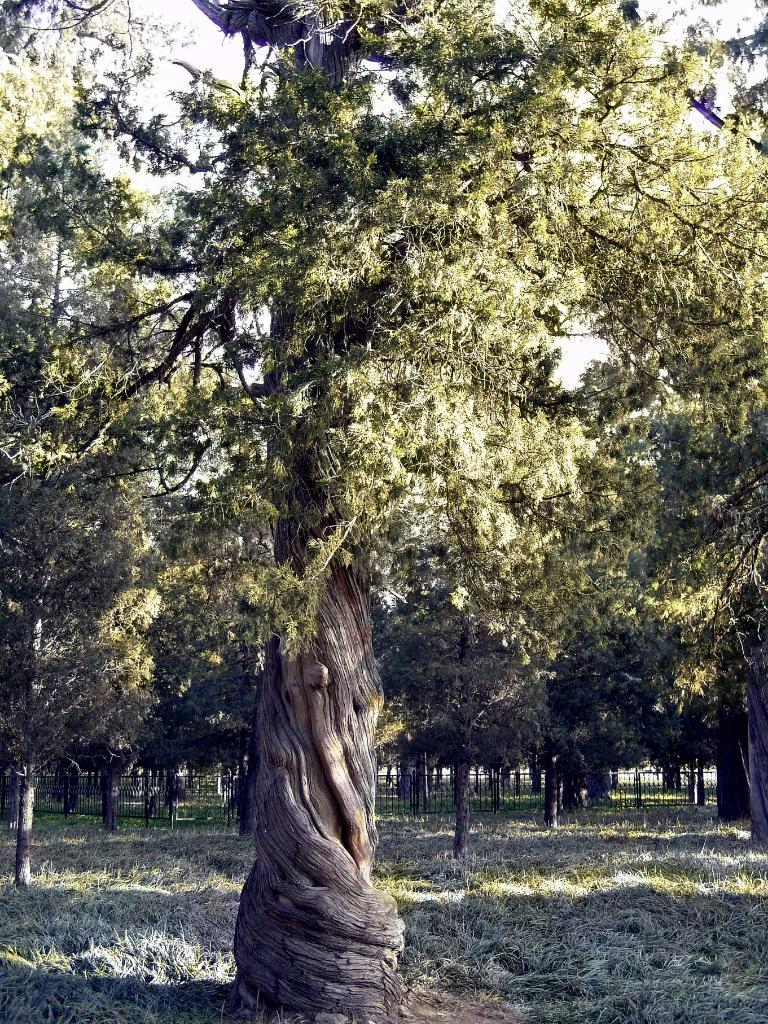What type of vegetation can be seen in the image? There are trees and grass in the image. Can you describe the natural environment depicted in the image? The image features trees and grass, which suggests a natural setting. What type of spark can be seen coming from the trees in the image? There is no spark present in the image; it features trees and grass in a natural setting. Can you tell me how many cats are resting on the grass in the image? There are no cats present in the image; it only features trees and grass. 